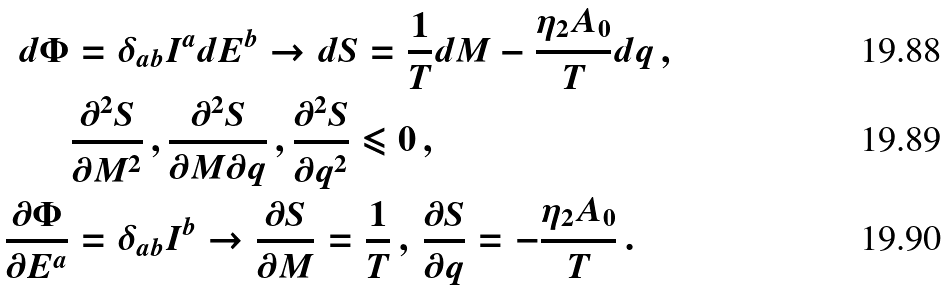Convert formula to latex. <formula><loc_0><loc_0><loc_500><loc_500>d \Phi & = \delta _ { a b } I ^ { a } d E ^ { b } \rightarrow d S = \frac { 1 } { T } d M - \frac { \eta _ { 2 } A _ { 0 } } { T } d q \, , \\ & \frac { \partial ^ { 2 } S } { \partial M ^ { 2 } } \, , \frac { \partial ^ { 2 } S } { \partial M \partial q } \, , \frac { \partial ^ { 2 } S } { \partial q ^ { 2 } } \leqslant 0 \, , \\ \frac { \partial \Phi } { \partial E ^ { a } } & = \delta _ { a b } I ^ { b } \rightarrow \frac { \partial S } { \partial M } = \frac { 1 } { T } \, , \, \frac { \partial S } { \partial q } = - \frac { \eta _ { 2 } A _ { 0 } } { T } \, .</formula> 